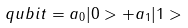Convert formula to latex. <formula><loc_0><loc_0><loc_500><loc_500>q u b i t = a _ { 0 } | 0 > + a _ { 1 } | 1 ></formula> 